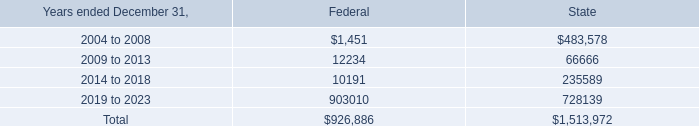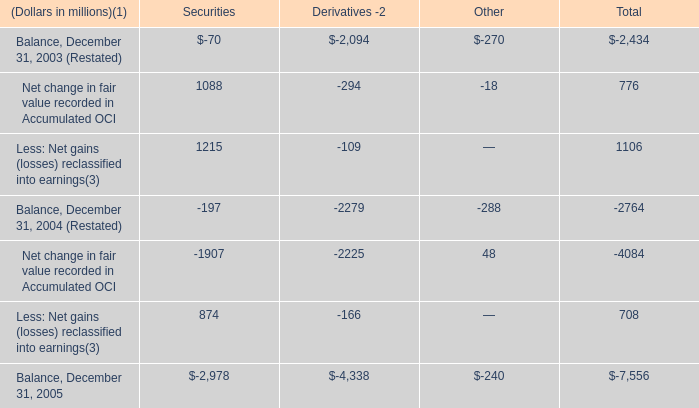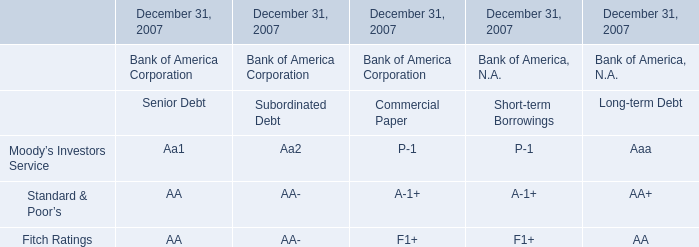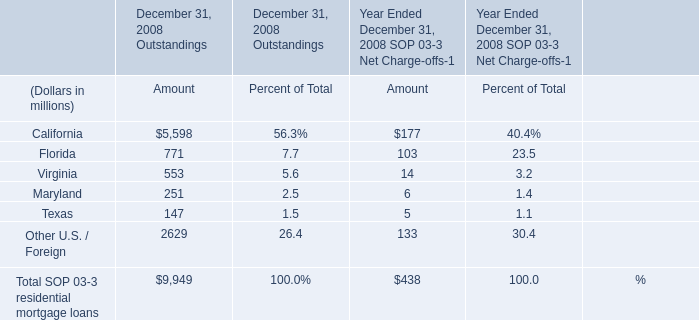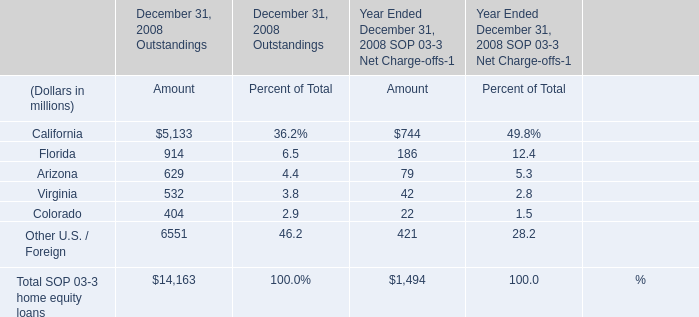What's the total amount of elements excluding those elements greater than 900 for December 31, 2008 Outstandings? (in million) 
Computations: ((629 + 532) + 404)
Answer: 1565.0. 